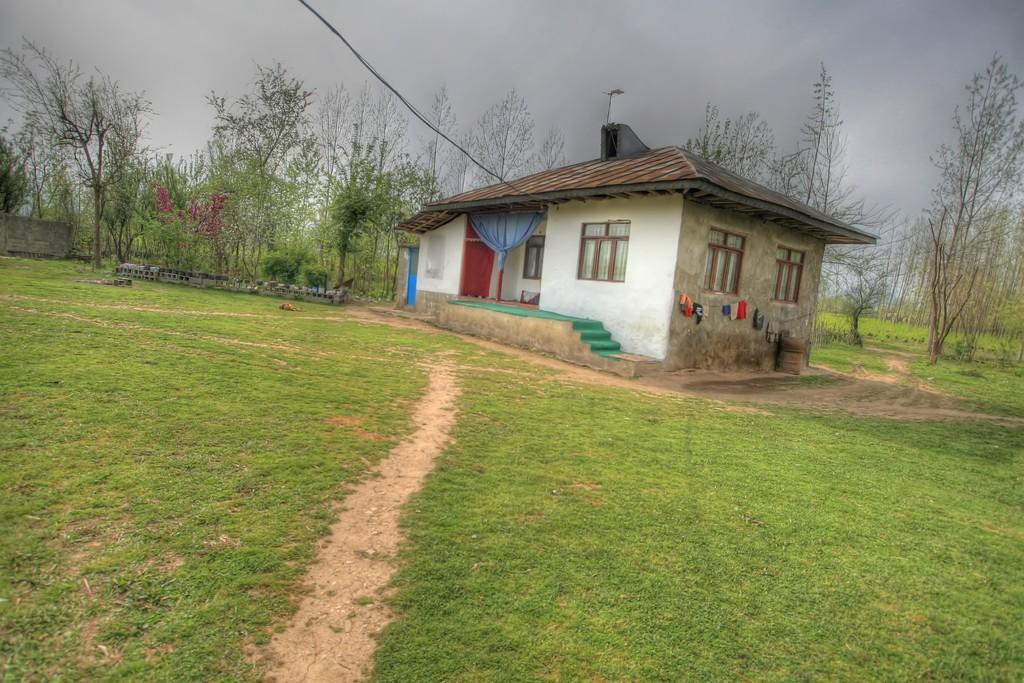Describe this image in one or two sentences. This image consists of a house along with windows and doors. In the front, we can see a curtain in blue color. At the bottom, there is green grass on the ground. On the left and right, there are trees. At the top, there are clouds in the sky. 